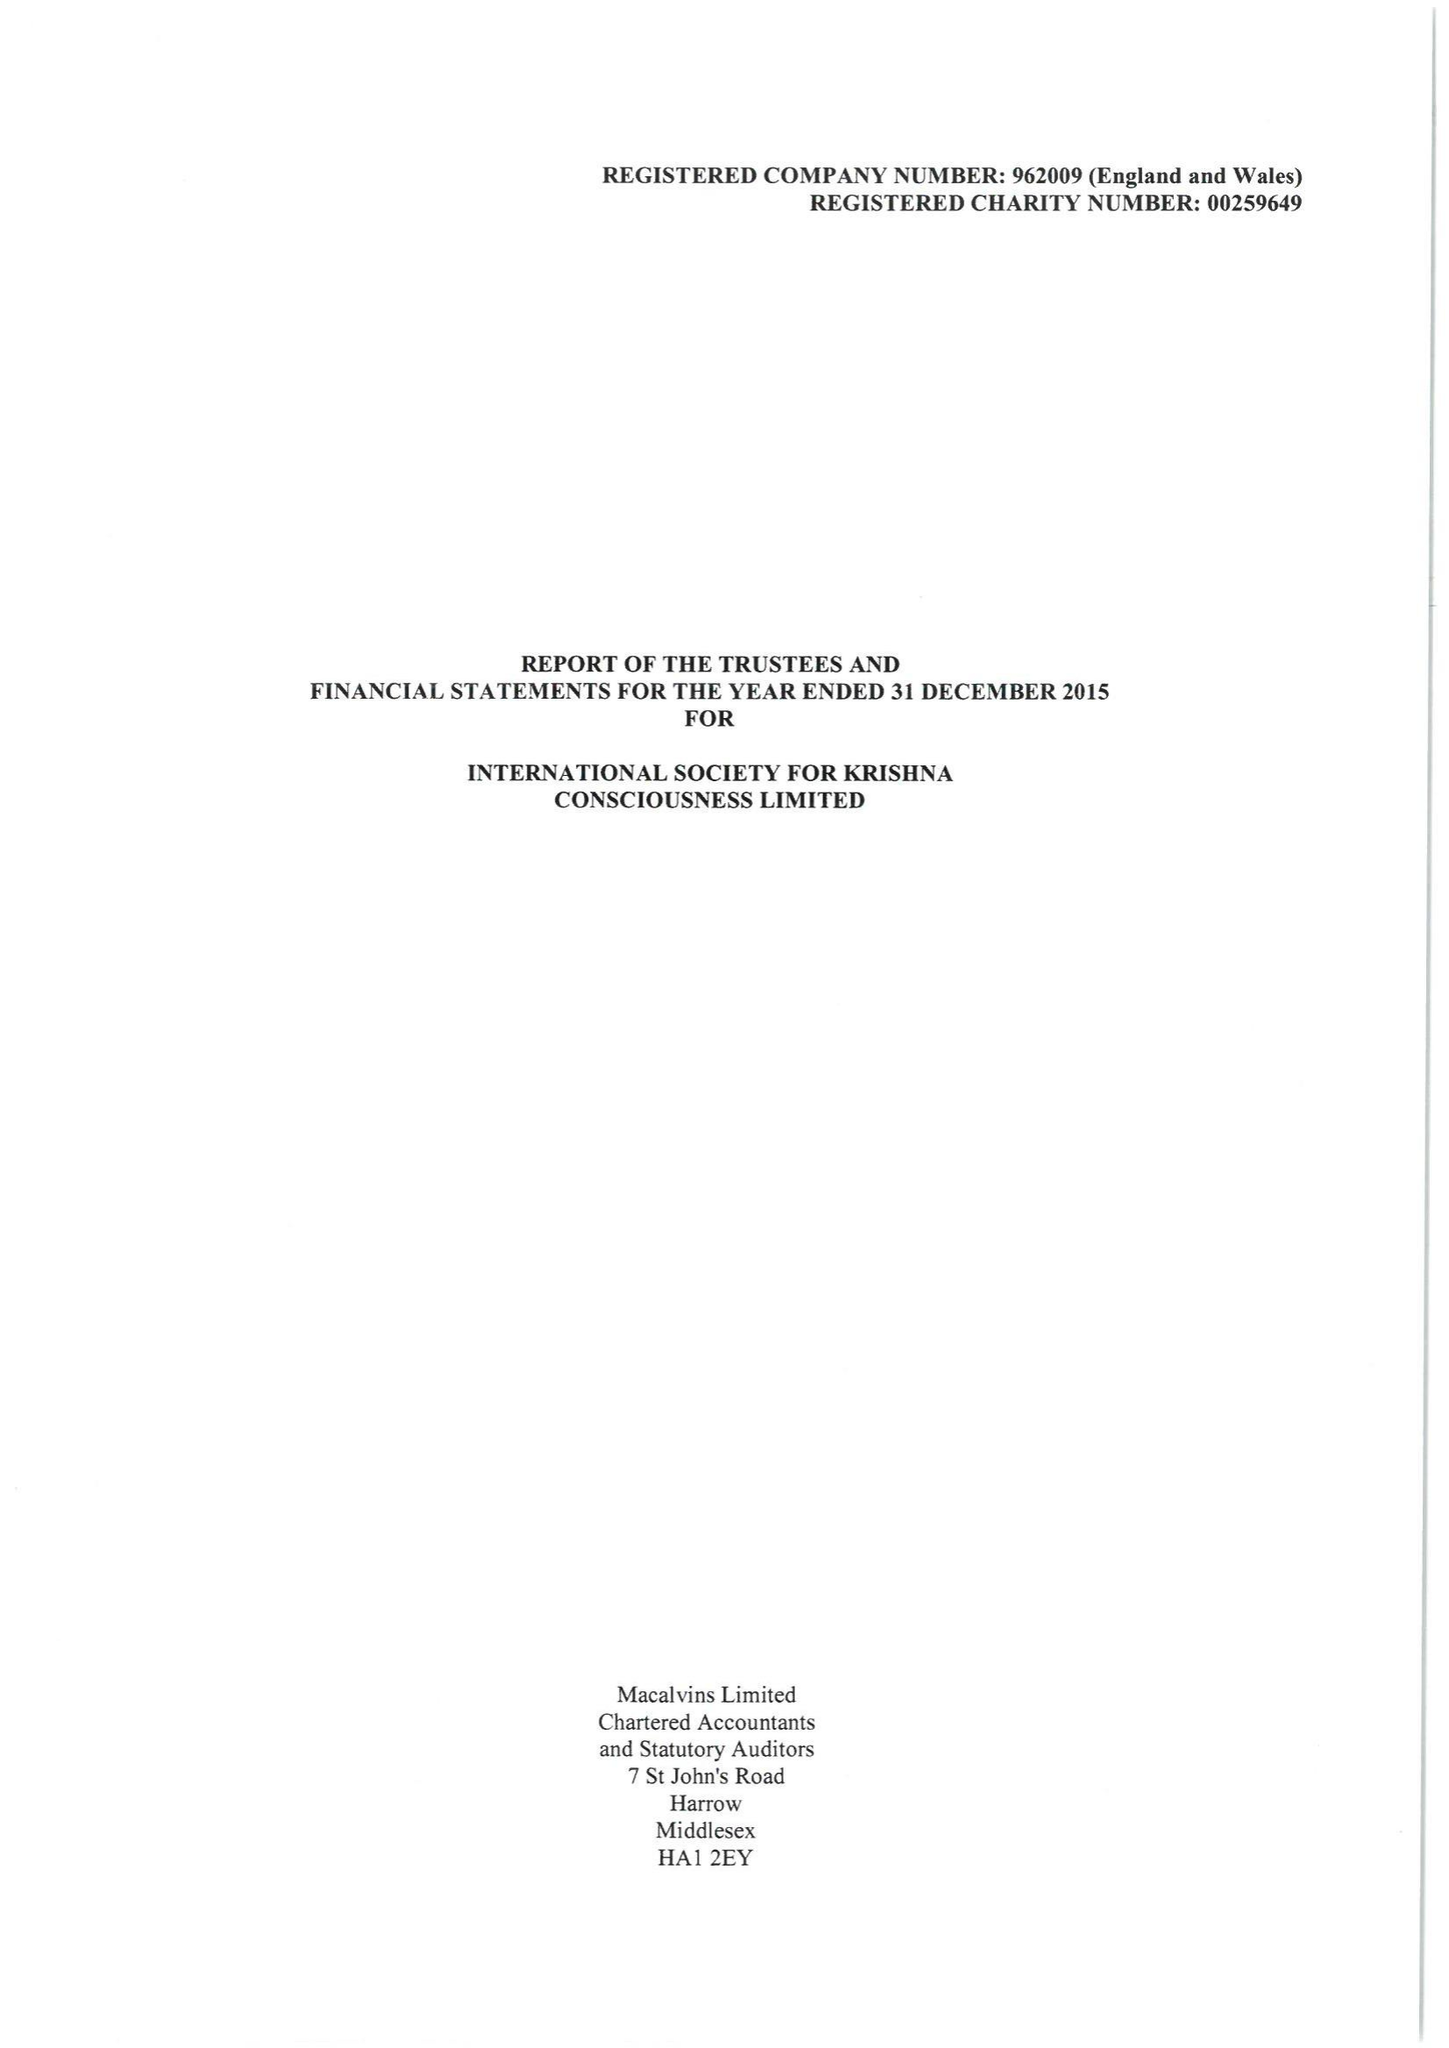What is the value for the address__post_town?
Answer the question using a single word or phrase. RADLETT 